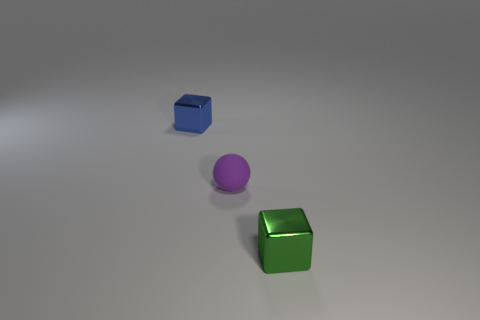What is the lighting like in the scene, and does it appear to be a natural or artificial environment? The lighting in the scene is soft and diffused, with no harsh shadows, suggesting an artificial environment potentially designed for a controlled setting, such as in a photography studio. Can you tell me more about the textures of the objects? The objects have a smooth and reflective texture, indicating that they are likely made of materials like plastic or metal with a polished finish. The reflective qualities create highlights and define the objects' three-dimensionality. 